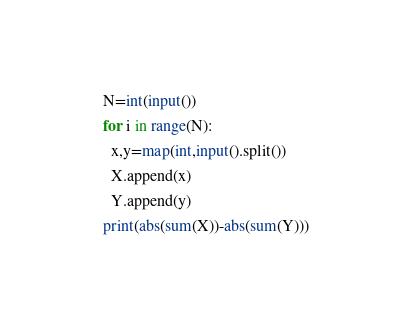Convert code to text. <code><loc_0><loc_0><loc_500><loc_500><_Python_>N=int(input())
for i in range(N):
  x,y=map(int,input().split())
  X.append(x)
  Y.append(y)
print(abs(sum(X))-abs(sum(Y)))</code> 